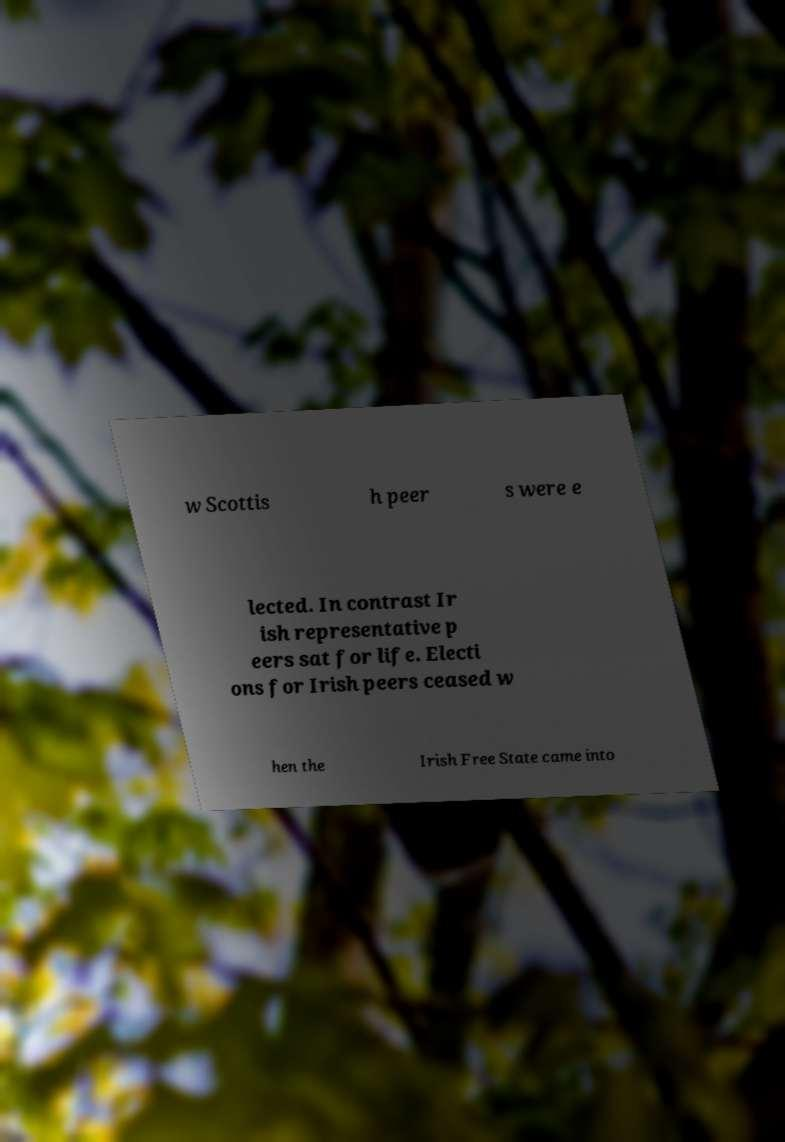Please read and relay the text visible in this image. What does it say? w Scottis h peer s were e lected. In contrast Ir ish representative p eers sat for life. Electi ons for Irish peers ceased w hen the Irish Free State came into 